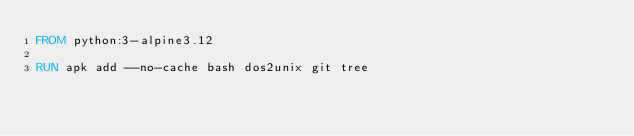Convert code to text. <code><loc_0><loc_0><loc_500><loc_500><_Dockerfile_>FROM python:3-alpine3.12

RUN apk add --no-cache bash dos2unix git tree
</code> 